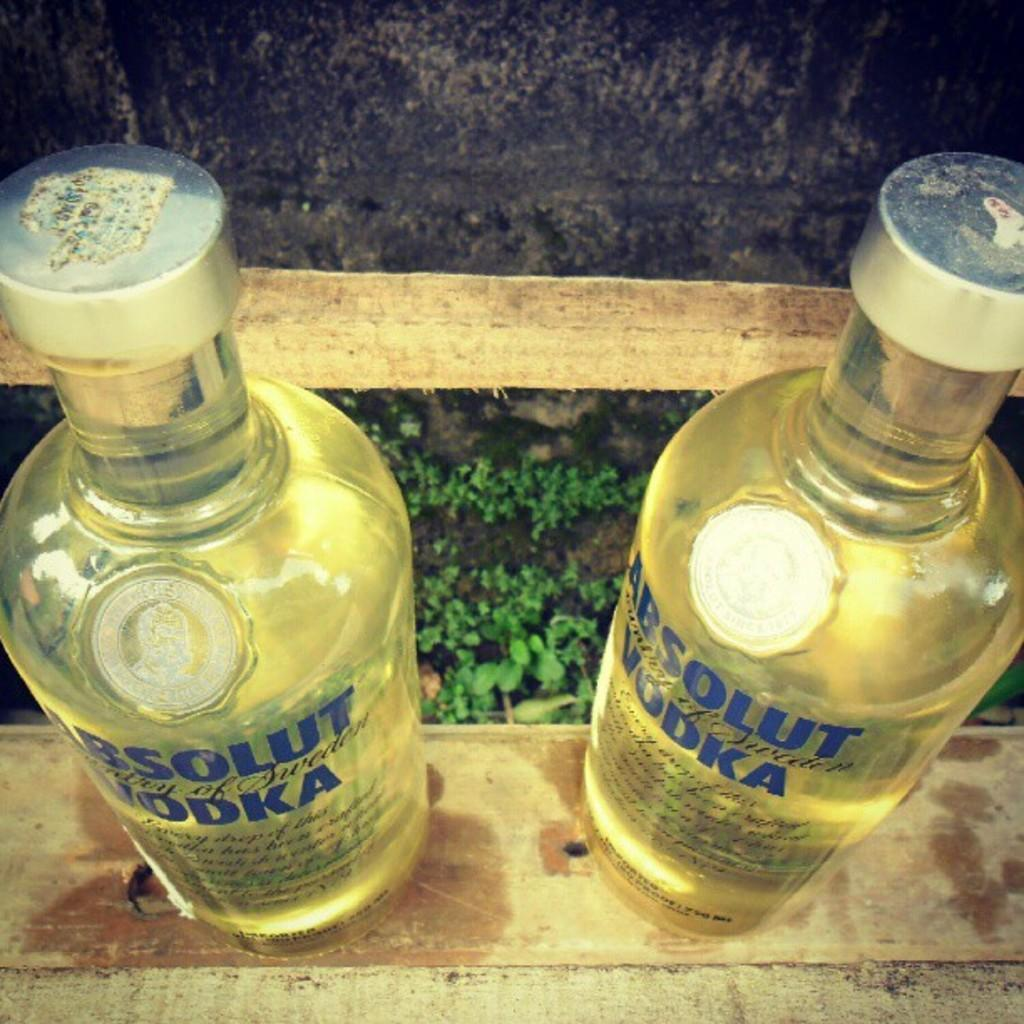How many bottles are visible in the image? There are two bottles in the image. What else can be seen at the bottom of the image? There are plants at the bottom of the image. What type of collar is the dog wearing in the image? There is no dog present in the image, so there is no collar to be seen. 